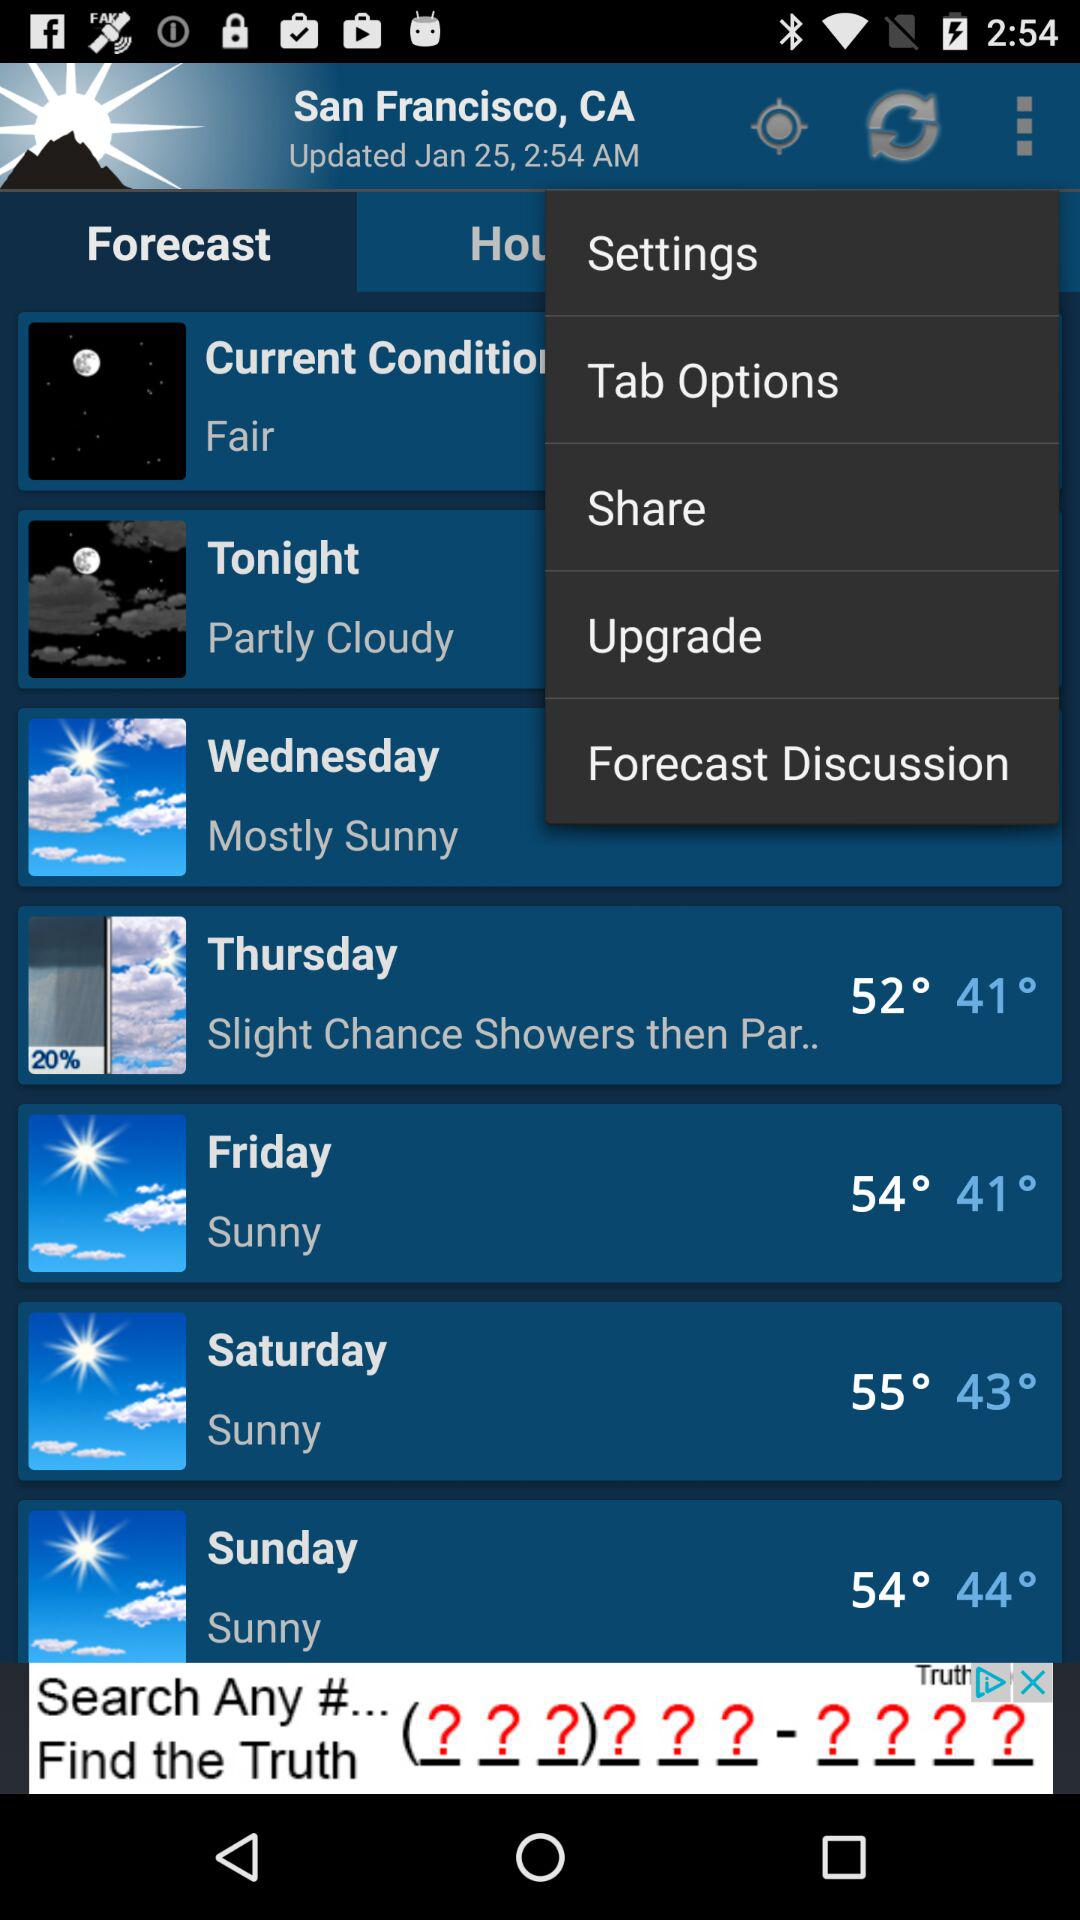What is the weather on Saturday? The weather is sunny. 